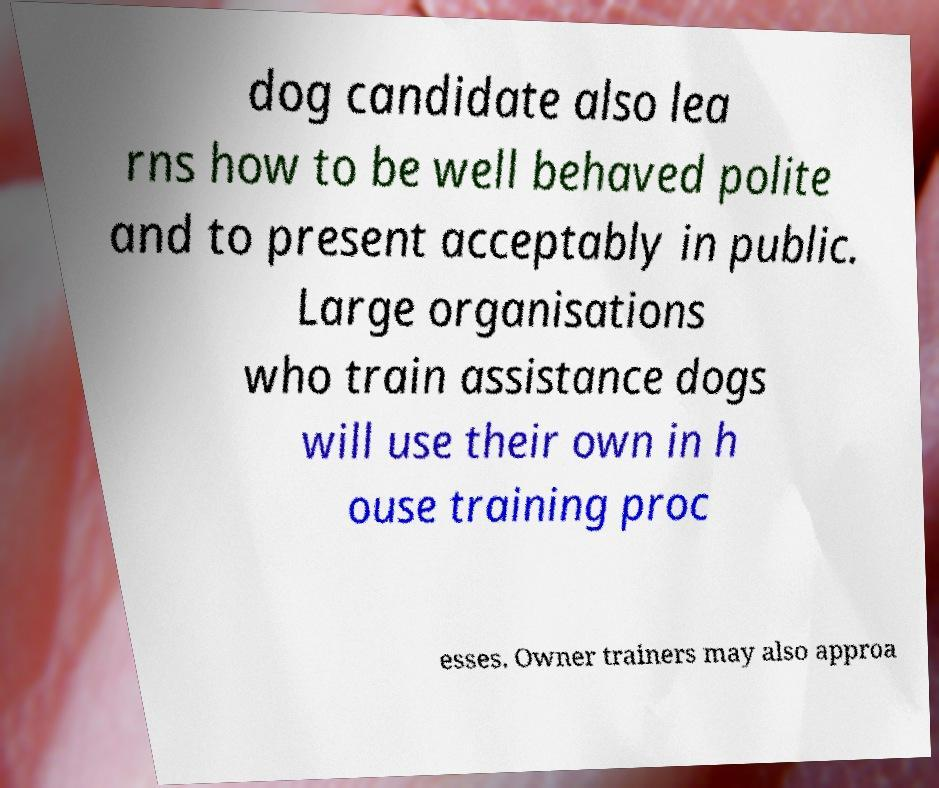I need the written content from this picture converted into text. Can you do that? dog candidate also lea rns how to be well behaved polite and to present acceptably in public. Large organisations who train assistance dogs will use their own in h ouse training proc esses. Owner trainers may also approa 